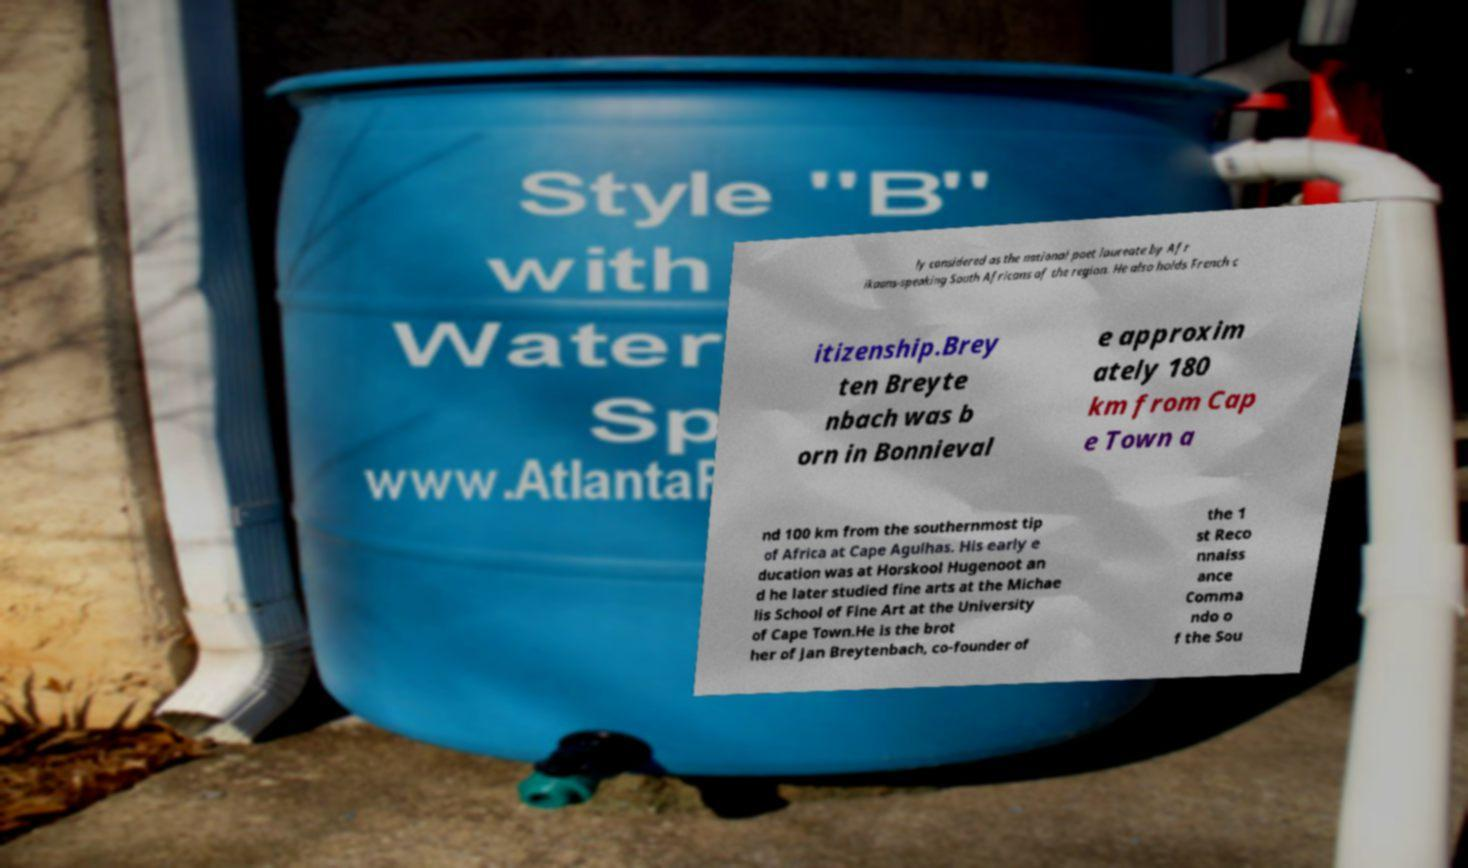For documentation purposes, I need the text within this image transcribed. Could you provide that? ly considered as the national poet laureate by Afr ikaans-speaking South Africans of the region. He also holds French c itizenship.Brey ten Breyte nbach was b orn in Bonnieval e approxim ately 180 km from Cap e Town a nd 100 km from the southernmost tip of Africa at Cape Agulhas. His early e ducation was at Horskool Hugenoot an d he later studied fine arts at the Michae lis School of Fine Art at the University of Cape Town.He is the brot her of Jan Breytenbach, co-founder of the 1 st Reco nnaiss ance Comma ndo o f the Sou 